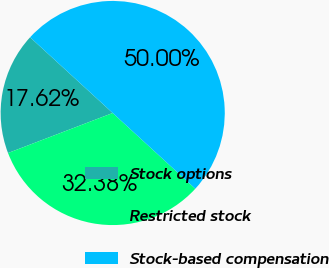Convert chart to OTSL. <chart><loc_0><loc_0><loc_500><loc_500><pie_chart><fcel>Stock options<fcel>Restricted stock<fcel>Stock-based compensation<nl><fcel>17.62%<fcel>32.38%<fcel>50.0%<nl></chart> 